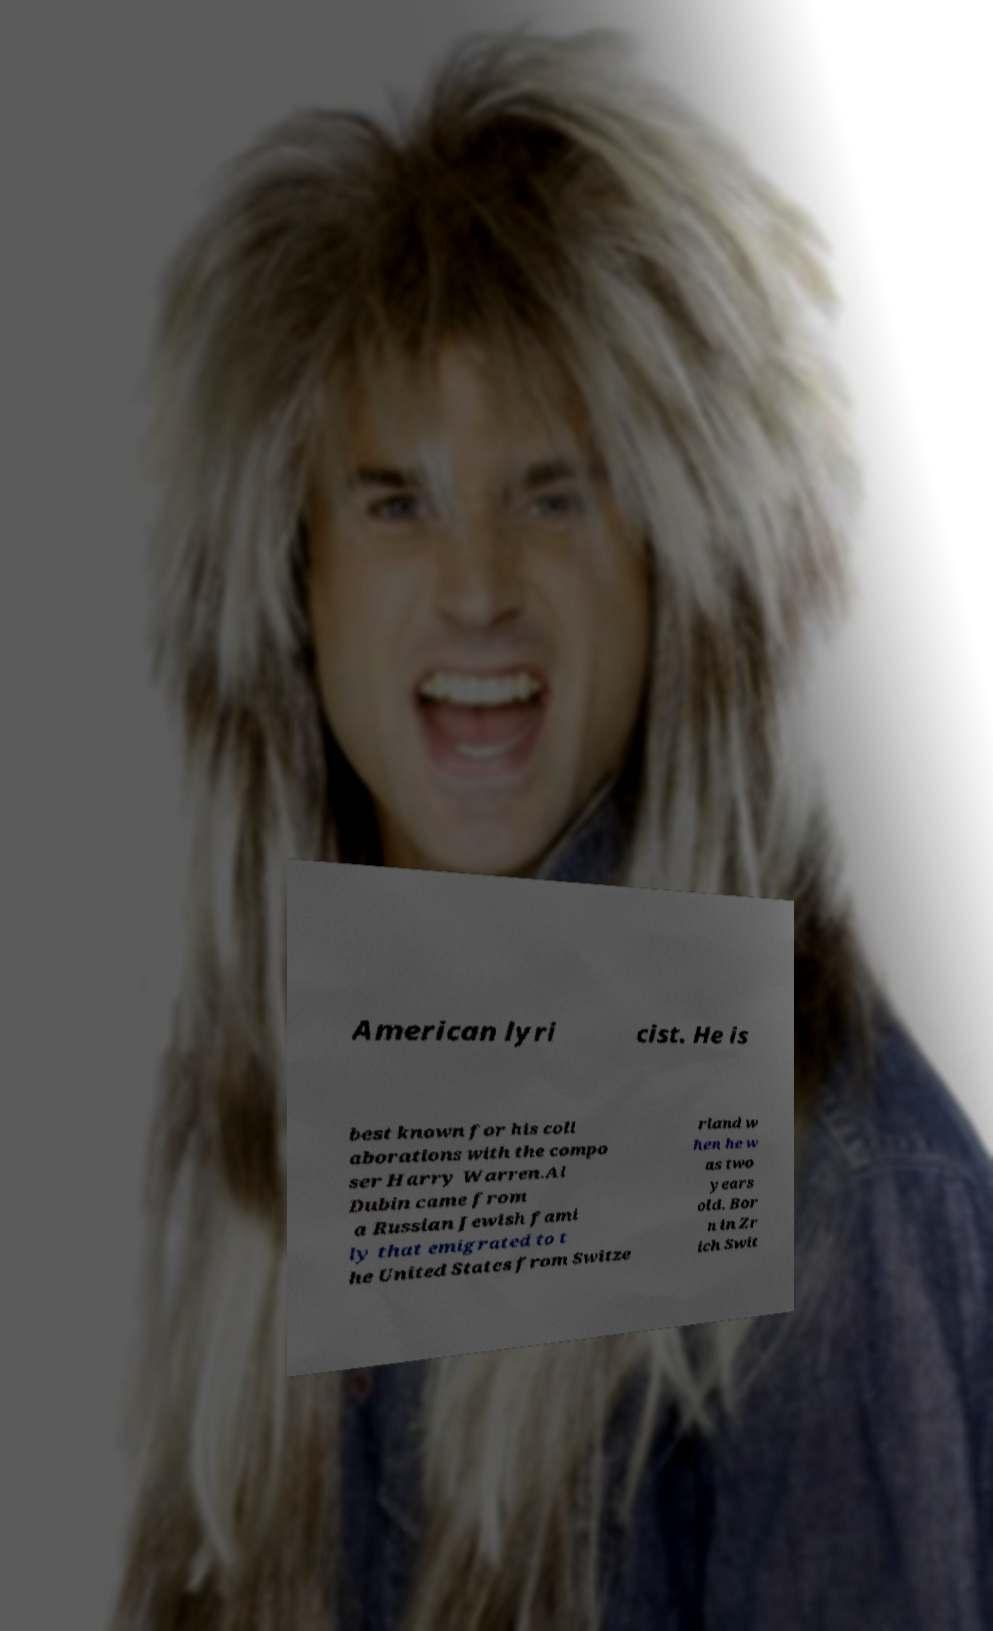What messages or text are displayed in this image? I need them in a readable, typed format. American lyri cist. He is best known for his coll aborations with the compo ser Harry Warren.Al Dubin came from a Russian Jewish fami ly that emigrated to t he United States from Switze rland w hen he w as two years old. Bor n in Zr ich Swit 